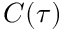<formula> <loc_0><loc_0><loc_500><loc_500>C ( \tau )</formula> 